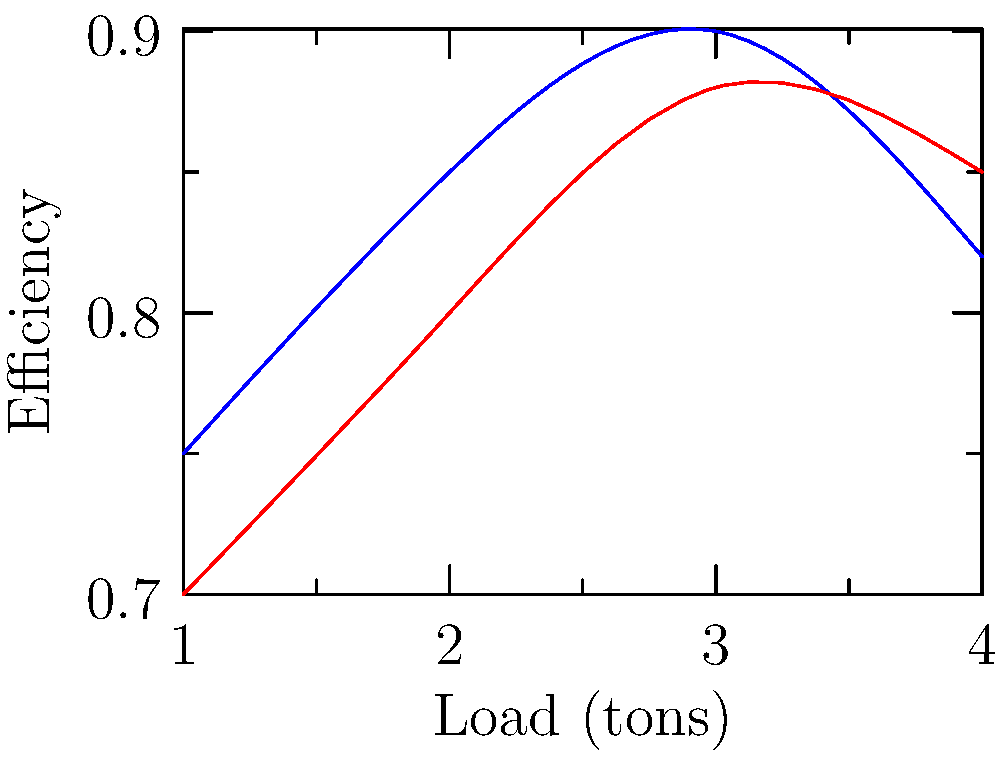A recycling truck manufacturer is testing two different gear ratios (A and B) for their transmission system. The graph shows the efficiency of each gear ratio under different load conditions. Which gear ratio would you recommend for a recycling truck that typically operates with loads between 2 and 3 tons, and why? To determine the best gear ratio for a recycling truck operating between 2 and 3 tons, we need to analyze the efficiency curves for both gear ratios A and B within this load range:

1. Examine the graph in the 2-3 ton range:
   - Gear Ratio A (blue line): Efficiency increases from about 0.85 to 0.9
   - Gear Ratio B (red line): Efficiency increases from about 0.8 to 0.88

2. Compare the efficiencies:
   - At 2 tons: Gear Ratio A ≈ 0.85, Gear Ratio B ≈ 0.8
   - At 3 tons: Gear Ratio A ≈ 0.9, Gear Ratio B ≈ 0.88

3. Calculate the average efficiency in the 2-3 ton range:
   - Gear Ratio A: $(0.85 + 0.9) / 2 = 0.875$
   - Gear Ratio B: $(0.8 + 0.88) / 2 = 0.84$

4. Consider the trend:
   - Gear Ratio A shows a steeper increase in efficiency from 2 to 3 tons
   - Gear Ratio B has a slightly flatter curve in this range

5. Conclusion:
   Gear Ratio A is more efficient throughout the 2-3 ton range and shows a more favorable trend as the load increases. This makes it better suited for a recycling truck that typically operates within this load range.
Answer: Gear Ratio A, due to higher efficiency in the 2-3 ton range. 